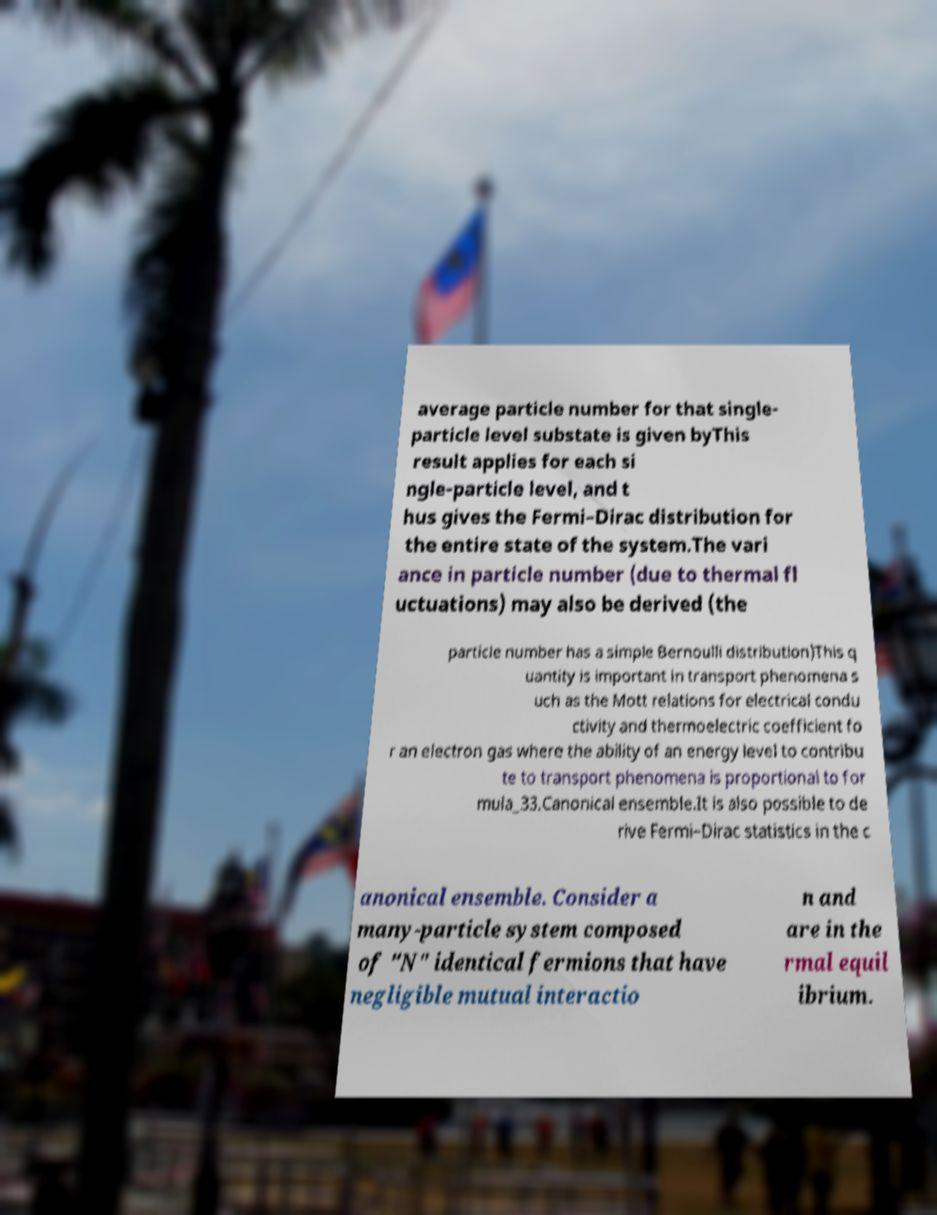Please read and relay the text visible in this image. What does it say? average particle number for that single- particle level substate is given byThis result applies for each si ngle-particle level, and t hus gives the Fermi–Dirac distribution for the entire state of the system.The vari ance in particle number (due to thermal fl uctuations) may also be derived (the particle number has a simple Bernoulli distribution)This q uantity is important in transport phenomena s uch as the Mott relations for electrical condu ctivity and thermoelectric coefficient fo r an electron gas where the ability of an energy level to contribu te to transport phenomena is proportional to for mula_33.Canonical ensemble.It is also possible to de rive Fermi–Dirac statistics in the c anonical ensemble. Consider a many-particle system composed of "N" identical fermions that have negligible mutual interactio n and are in the rmal equil ibrium. 